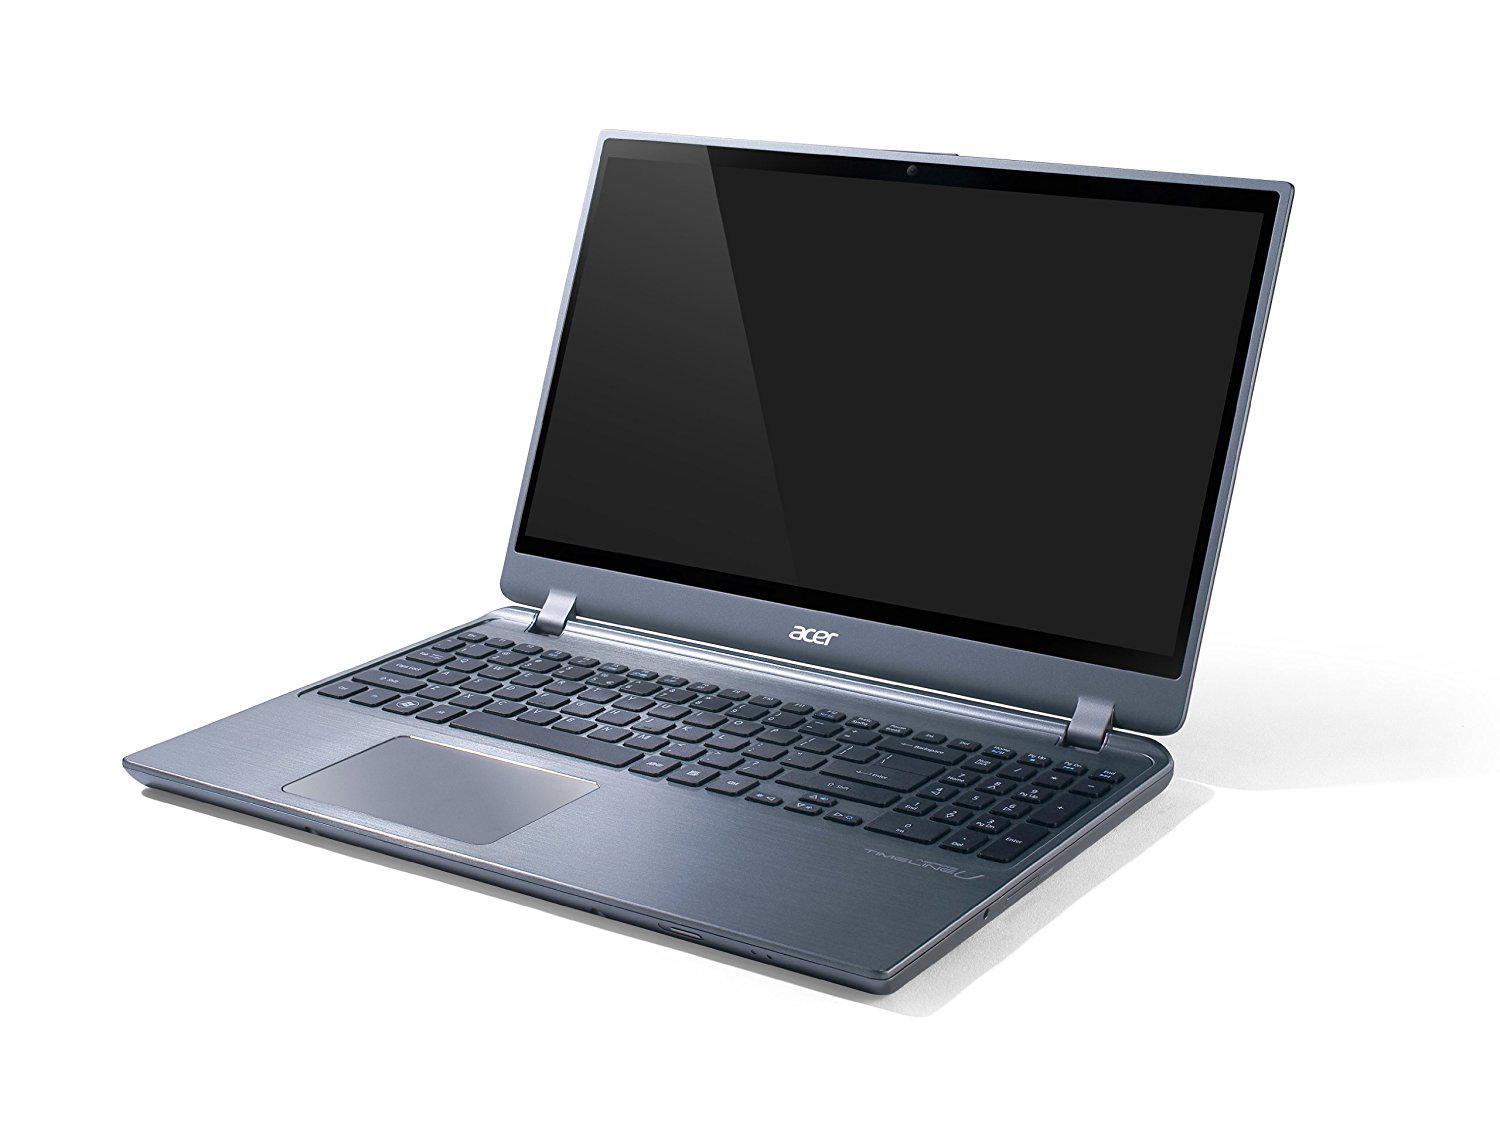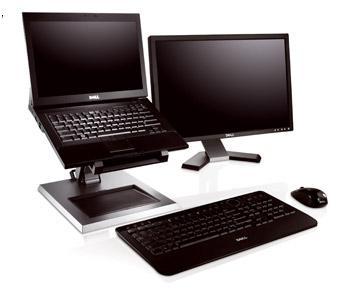The first image is the image on the left, the second image is the image on the right. Considering the images on both sides, is "There are 3 or more books being displayed with laptops." valid? Answer yes or no. No. The first image is the image on the left, the second image is the image on the right. Examine the images to the left and right. Is the description "There is one computer mouse in these." accurate? Answer yes or no. Yes. 